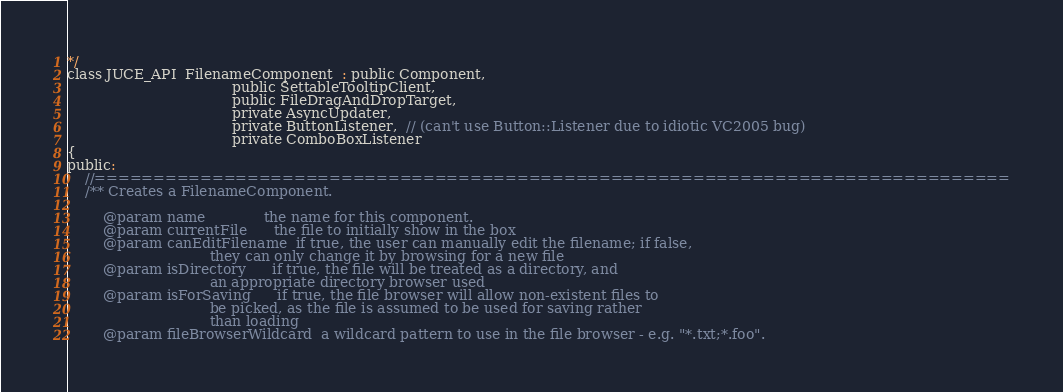Convert code to text. <code><loc_0><loc_0><loc_500><loc_500><_C_>*/
class JUCE_API  FilenameComponent  : public Component,
                                     public SettableTooltipClient,
                                     public FileDragAndDropTarget,
                                     private AsyncUpdater,
                                     private ButtonListener,  // (can't use Button::Listener due to idiotic VC2005 bug)
                                     private ComboBoxListener
{
public:
    //==============================================================================
    /** Creates a FilenameComponent.

        @param name             the name for this component.
        @param currentFile      the file to initially show in the box
        @param canEditFilename  if true, the user can manually edit the filename; if false,
                                they can only change it by browsing for a new file
        @param isDirectory      if true, the file will be treated as a directory, and
                                an appropriate directory browser used
        @param isForSaving      if true, the file browser will allow non-existent files to
                                be picked, as the file is assumed to be used for saving rather
                                than loading
        @param fileBrowserWildcard  a wildcard pattern to use in the file browser - e.g. "*.txt;*.foo".</code> 